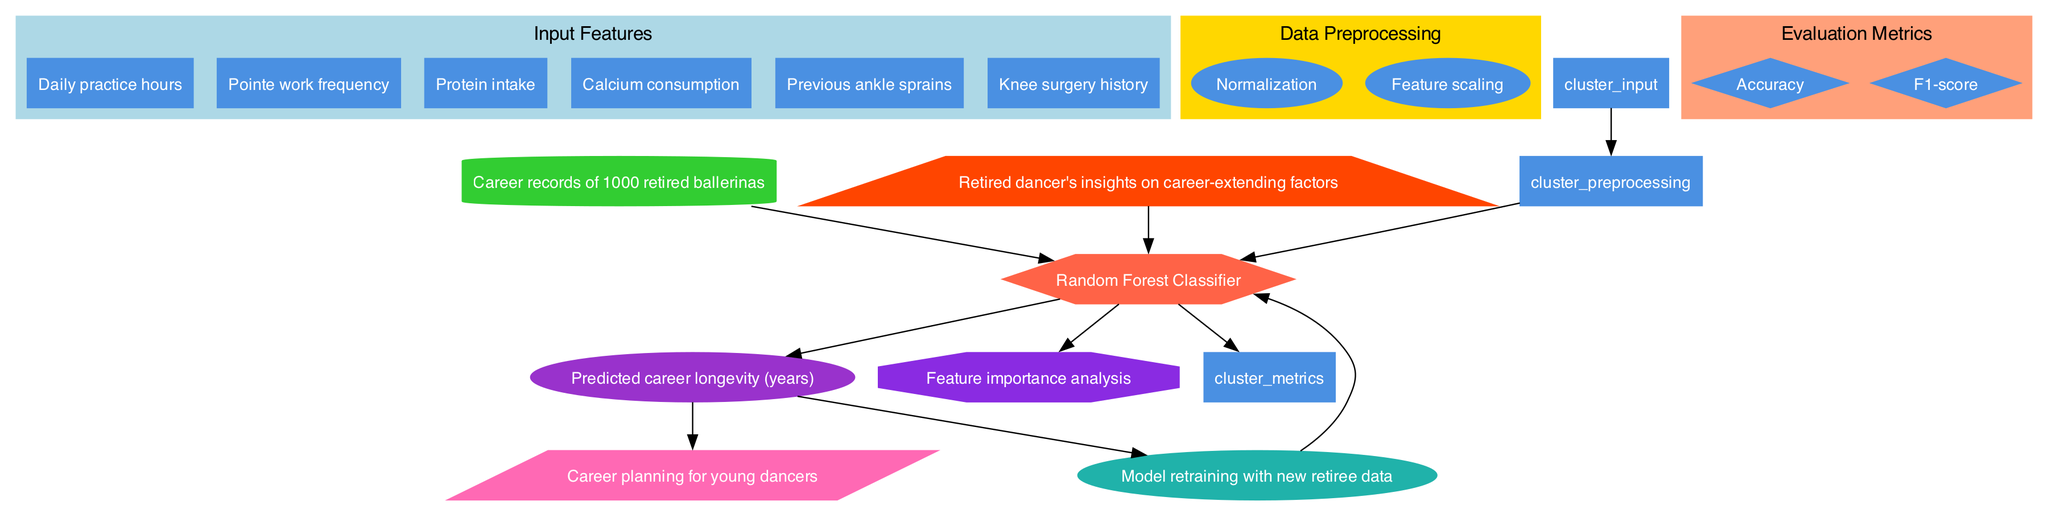What are the input features in this model? The diagram lists six input features: Daily practice hours, Pointe work frequency, Protein intake, Calcium consumption, Previous ankle sprains, and Knee surgery history, which can be found in the 'Input Features' section of the diagram.
Answer: Daily practice hours, Pointe work frequency, Protein intake, Calcium consumption, Previous ankle sprains, Knee surgery history How many evaluation metrics are shown? The 'Evaluation Metrics' section includes two distinct metrics: Accuracy and F1-score. In total, there are two separate nodes representing these metrics.
Answer: 2 What type of model is used in this diagram? The model used is specified as a Random Forest Classifier, which is represented as a hexagon node in the diagram.
Answer: Random Forest Classifier What feedback mechanism is indicated in the diagram? The diagram includes a feedback loop that mentions "Model retraining with new retiree data," suggesting that new data is used to improve the model.
Answer: Model retraining with new retiree data Which feature is likely to have the most influence on the output according to the expert input? The diagram includes a node named "Expert input" that signifies the influence of a retired dancer's insights on career-extending factors, indicating a consideration of practical experience in the predictions.
Answer: Retired dancer's insights on career-extending factors What does the output of the model represent? The output of the model is indicated to be the "Predicted career longevity (years)," showing that the model aims to estimate how long a dancer's career might last.
Answer: Predicted career longevity (years) How does the training data relate to the model? The training data consists of "Career records of 1000 retired ballerinas," which serves as the foundational dataset from which the model learns and makes predictions.
Answer: Career records of 1000 retired ballerinas What is the application of this machine learning model? The model is designed for "Career planning for young dancers," which indicates its intended use for guiding dancers in their career development.
Answer: Career planning for young dancers 